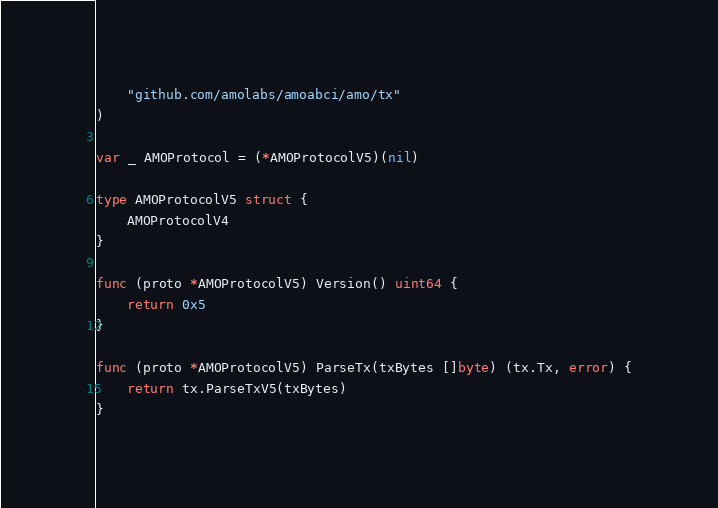<code> <loc_0><loc_0><loc_500><loc_500><_Go_>	"github.com/amolabs/amoabci/amo/tx"
)

var _ AMOProtocol = (*AMOProtocolV5)(nil)

type AMOProtocolV5 struct {
	AMOProtocolV4
}

func (proto *AMOProtocolV5) Version() uint64 {
	return 0x5
}

func (proto *AMOProtocolV5) ParseTx(txBytes []byte) (tx.Tx, error) {
	return tx.ParseTxV5(txBytes)
}
</code> 